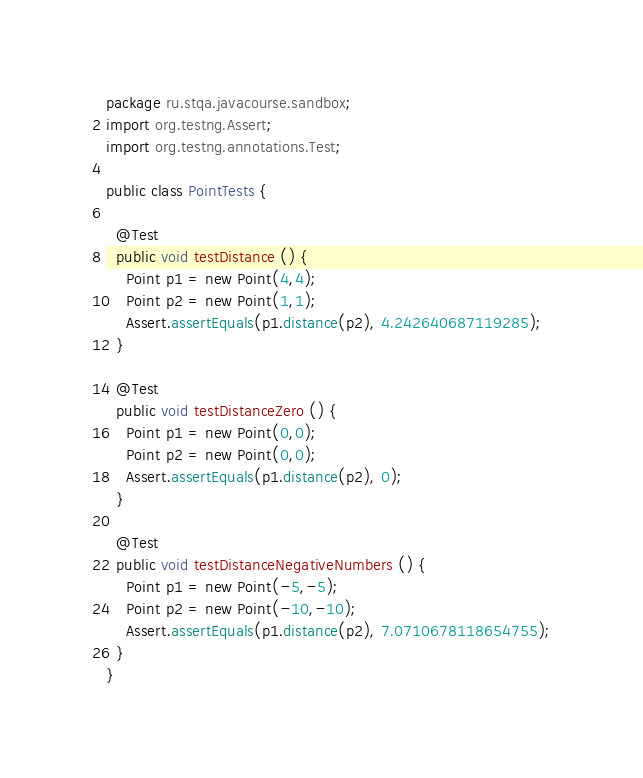Convert code to text. <code><loc_0><loc_0><loc_500><loc_500><_Java_>package ru.stqa.javacourse.sandbox;
import org.testng.Assert;
import org.testng.annotations.Test;

public class PointTests {

  @Test
  public void testDistance () {
    Point p1 = new Point(4,4);
    Point p2 = new Point(1,1);
    Assert.assertEquals(p1.distance(p2), 4.242640687119285);
  }

  @Test
  public void testDistanceZero () {
    Point p1 = new Point(0,0);
    Point p2 = new Point(0,0);
    Assert.assertEquals(p1.distance(p2), 0);
  }

  @Test
  public void testDistanceNegativeNumbers () {
    Point p1 = new Point(-5,-5);
    Point p2 = new Point(-10,-10);
    Assert.assertEquals(p1.distance(p2), 7.0710678118654755);
  }
}
</code> 